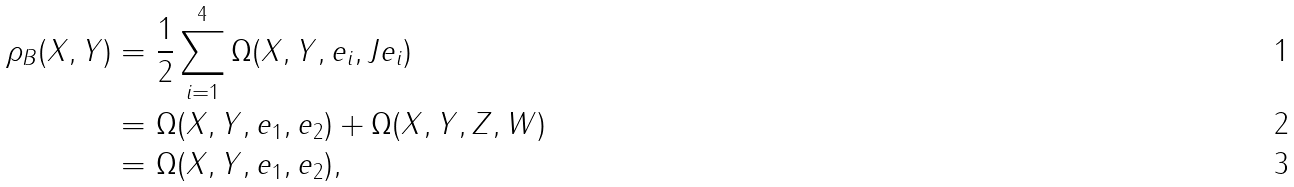<formula> <loc_0><loc_0><loc_500><loc_500>\rho _ { B } ( X , Y ) = & \ \frac { 1 } { 2 } \sum _ { i = 1 } ^ { 4 } \Omega ( X , Y , e _ { i } , J e _ { i } ) \\ = & \ \Omega ( X , Y , e _ { 1 } , e _ { 2 } ) + \Omega ( X , Y , Z , W ) \\ = & \ \Omega ( X , Y , e _ { 1 } , e _ { 2 } ) ,</formula> 